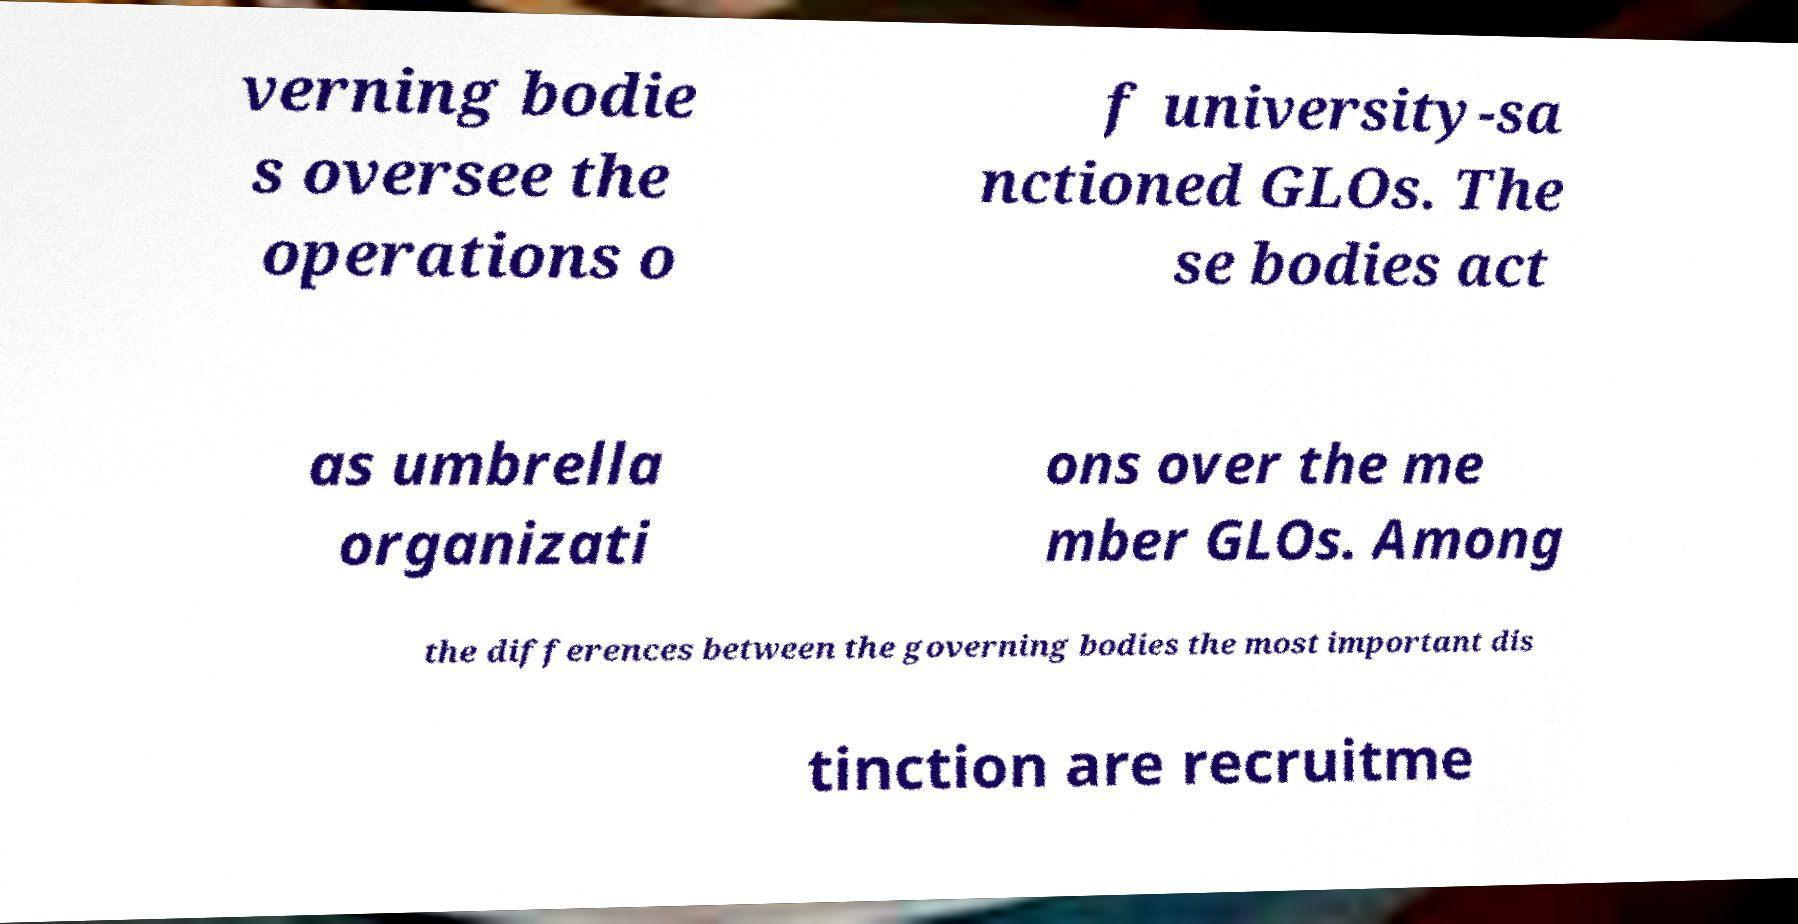Please read and relay the text visible in this image. What does it say? verning bodie s oversee the operations o f university-sa nctioned GLOs. The se bodies act as umbrella organizati ons over the me mber GLOs. Among the differences between the governing bodies the most important dis tinction are recruitme 